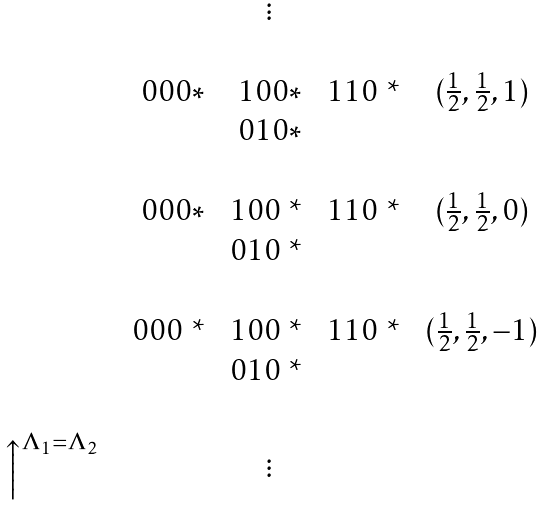<formula> <loc_0><loc_0><loc_500><loc_500>\begin{matrix} & & & \vdots \\ \\ & & 0 0 0 * & 1 0 0 * & 1 1 0 $ * $ & ( \frac { 1 } { 2 } , \frac { 1 } { 2 } , 1 ) \\ & & & 0 1 0 * & \\ \\ & & 0 0 0 * & 1 0 0 $ * $ & 1 1 0 $ * $ & ( \frac { 1 } { 2 } , \frac { 1 } { 2 } , 0 ) \\ & & & 0 1 0 $ * $ & \\ \\ & & 0 0 0 $ * $ & 1 0 0 $ * $ & 1 1 0 $ * $ & ( \frac { 1 } { 2 } , \frac { 1 } { 2 } , - 1 ) \\ & & & 0 1 0 $ * $ & \\ \\ \Big { \uparrow } ^ { \Lambda _ { 1 } = \Lambda _ { 2 } } & & & \vdots \\ \end{matrix}</formula> 